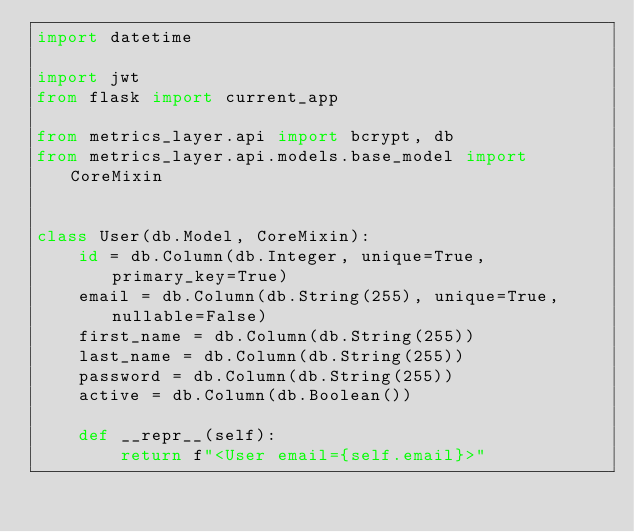<code> <loc_0><loc_0><loc_500><loc_500><_Python_>import datetime

import jwt
from flask import current_app

from metrics_layer.api import bcrypt, db
from metrics_layer.api.models.base_model import CoreMixin


class User(db.Model, CoreMixin):
    id = db.Column(db.Integer, unique=True, primary_key=True)
    email = db.Column(db.String(255), unique=True, nullable=False)
    first_name = db.Column(db.String(255))
    last_name = db.Column(db.String(255))
    password = db.Column(db.String(255))
    active = db.Column(db.Boolean())

    def __repr__(self):
        return f"<User email={self.email}>"
</code> 